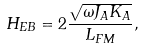<formula> <loc_0><loc_0><loc_500><loc_500>H _ { E B } = 2 \frac { \sqrt { \omega J _ { A } K _ { A } } } { L _ { F M } } ,</formula> 